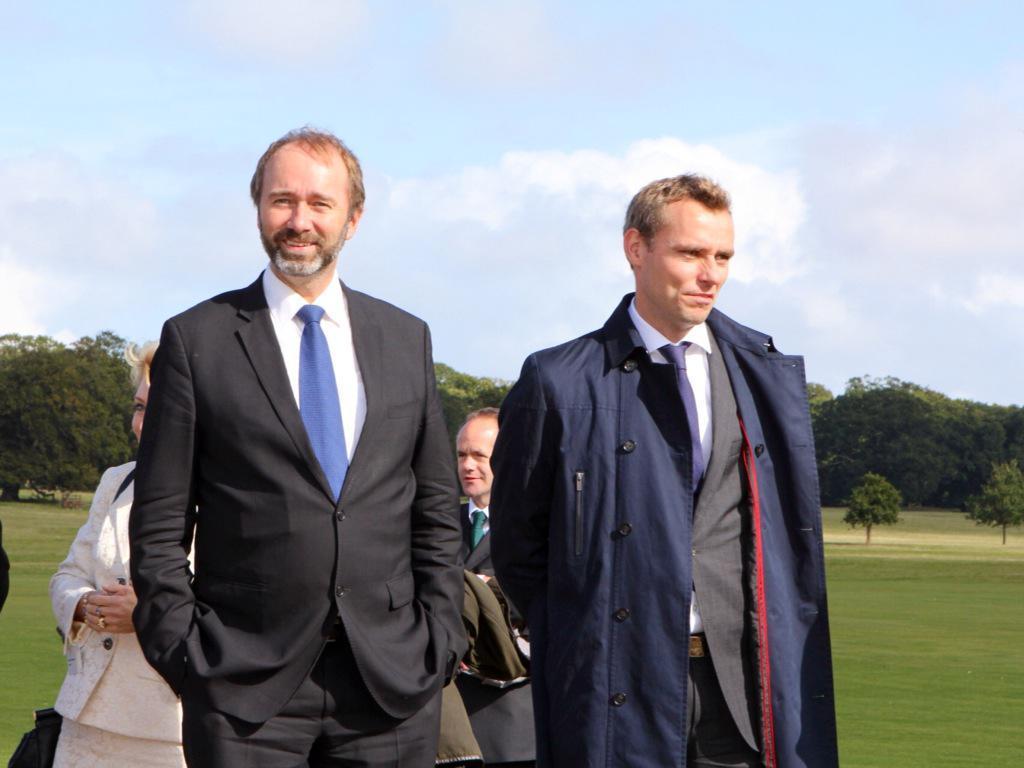Can you describe this image briefly? In this image I can see the group of people with different color dresses. These people are standing on the ground. In the back there are many trees, clouds and the sky. I can see one person wearing the bag. 